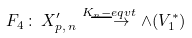<formula> <loc_0><loc_0><loc_500><loc_500>F _ { 4 } \, \colon \, X _ { p , \, n } ^ { \prime } \stackrel { K _ { n } - e q v t } { \longrightarrow } \wedge ( V _ { 1 } ^ { \ast } )</formula> 